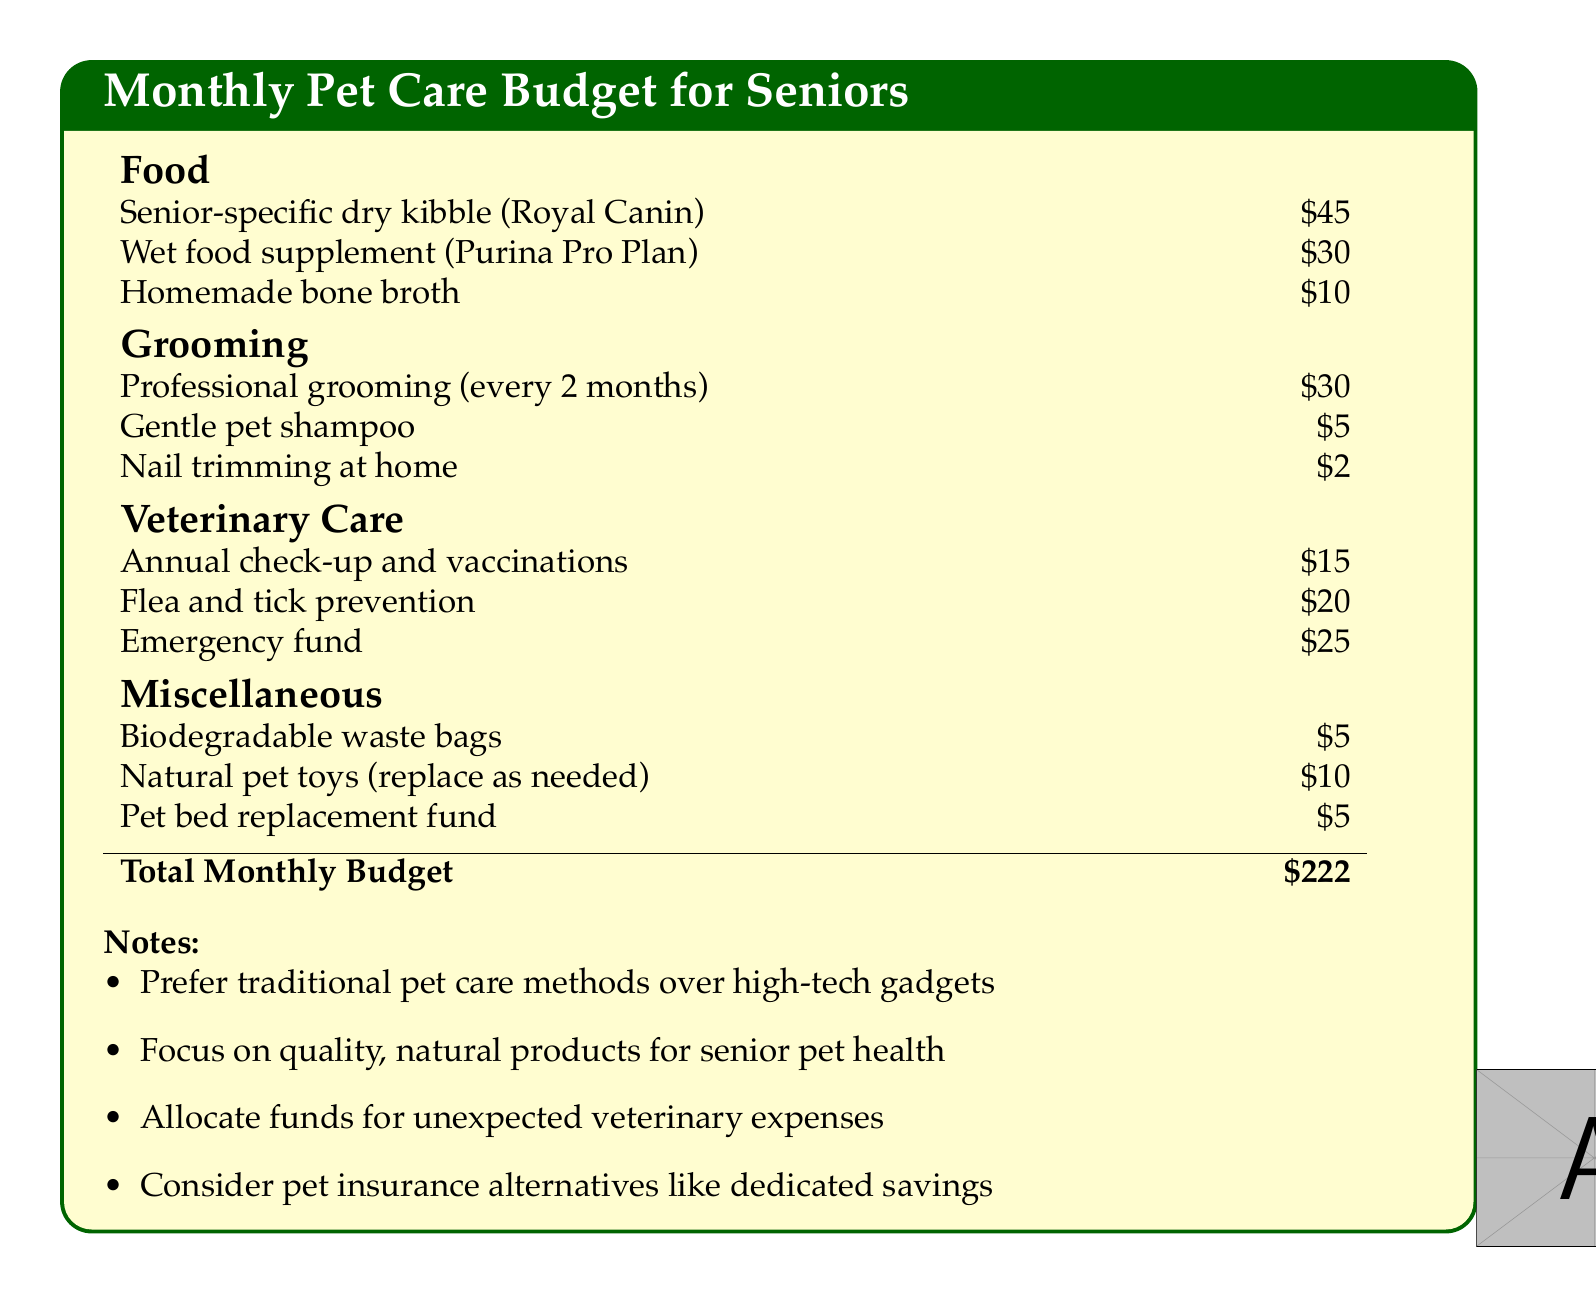What is the total monthly budget for pet care? The total monthly budget is presented as the sum of all pet care expenses in the document.
Answer: $222 How much is allocated for senior-specific dry kibble? This detail shows the cost of the main food item for senior pets listed in the budget.
Answer: $45 What is the cost of professional grooming? This refers to the expense for grooming services mentioned in the grooming section of the budget.
Answer: $30 How often is the professional grooming done? The frequency of the professional grooming as specified in the grooming section indicates a schedule related to pet care.
Answer: Every 2 months What amount is set aside for the emergency fund? The emergency fund is included in the veterinary care section.
Answer: $25 How much do biodegradable waste bags cost? This is the specific expense for waste bags listed under miscellaneous.
Answer: $5 What type of shampoo is recommended? The document specifies the kind of shampoo for pet grooming.
Answer: Gentle pet shampoo What is noted about product preferences? This note encourages a specific approach towards product selections in the document.
Answer: Traditional pet care methods What is allocated for the flea and tick prevention? The budget provides a clear figure for flea and tick control under veterinary care.
Answer: $20 